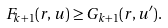<formula> <loc_0><loc_0><loc_500><loc_500>F _ { k + 1 } ( r , u ) \geq G _ { k + 1 } ( r , u ^ { \prime } ) .</formula> 